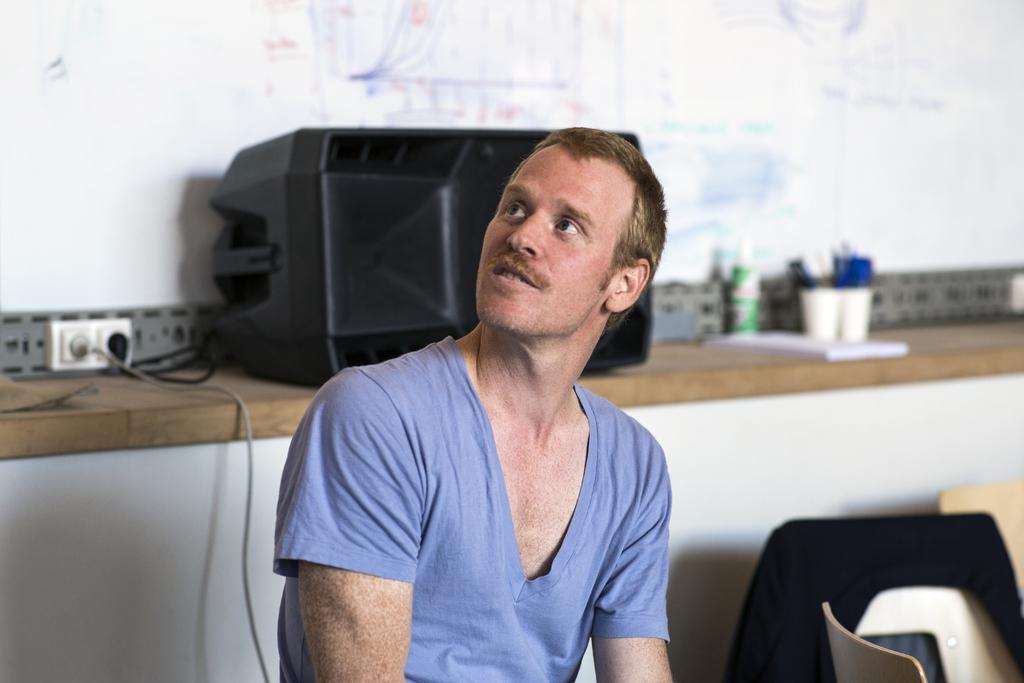Could you give a brief overview of what you see in this image? There is a man sitting and we can see chairs, behind him we can see device, cables and objects on the wooden platform and we can see wall. 